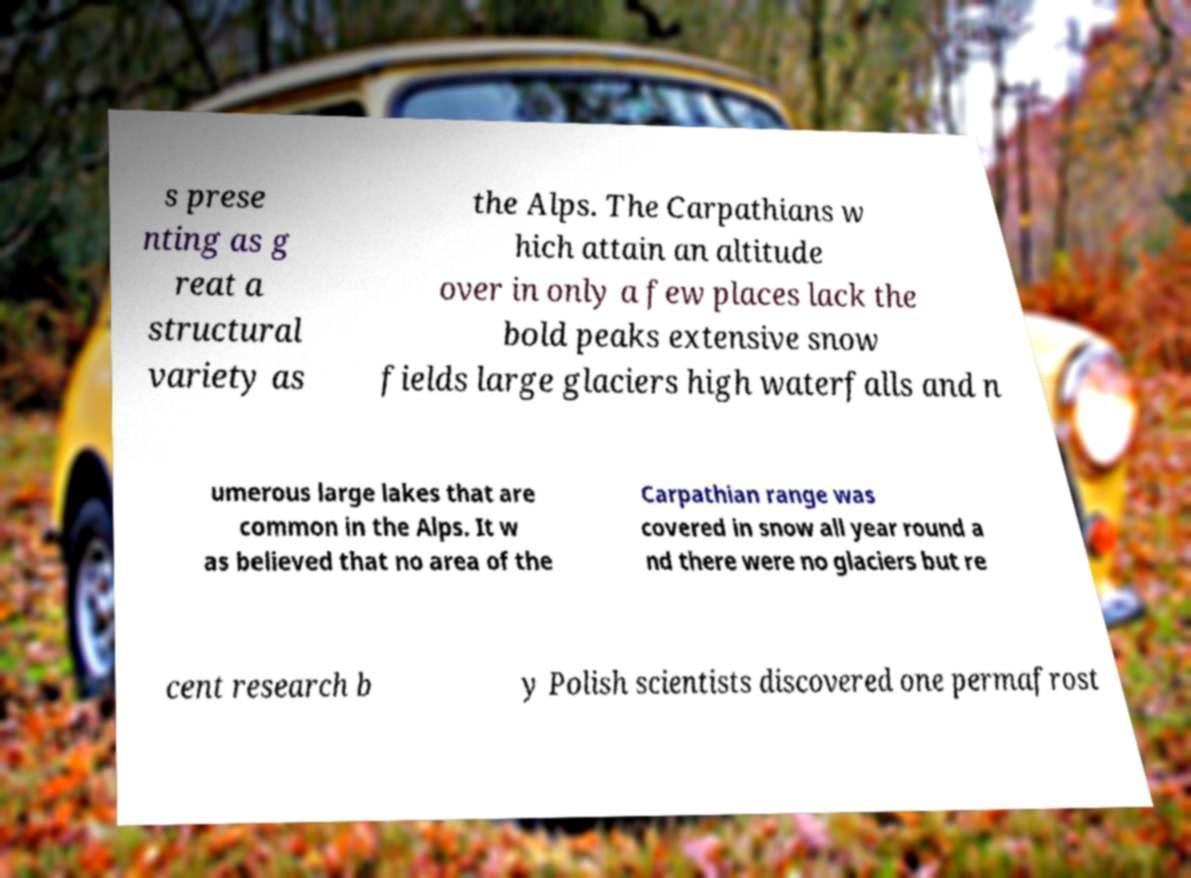Can you read and provide the text displayed in the image?This photo seems to have some interesting text. Can you extract and type it out for me? s prese nting as g reat a structural variety as the Alps. The Carpathians w hich attain an altitude over in only a few places lack the bold peaks extensive snow fields large glaciers high waterfalls and n umerous large lakes that are common in the Alps. It w as believed that no area of the Carpathian range was covered in snow all year round a nd there were no glaciers but re cent research b y Polish scientists discovered one permafrost 